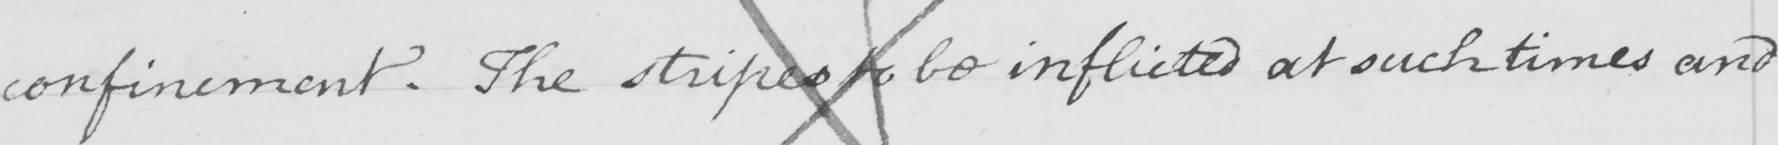What is written in this line of handwriting? confinement . The stripes to be inflicted at such times and 